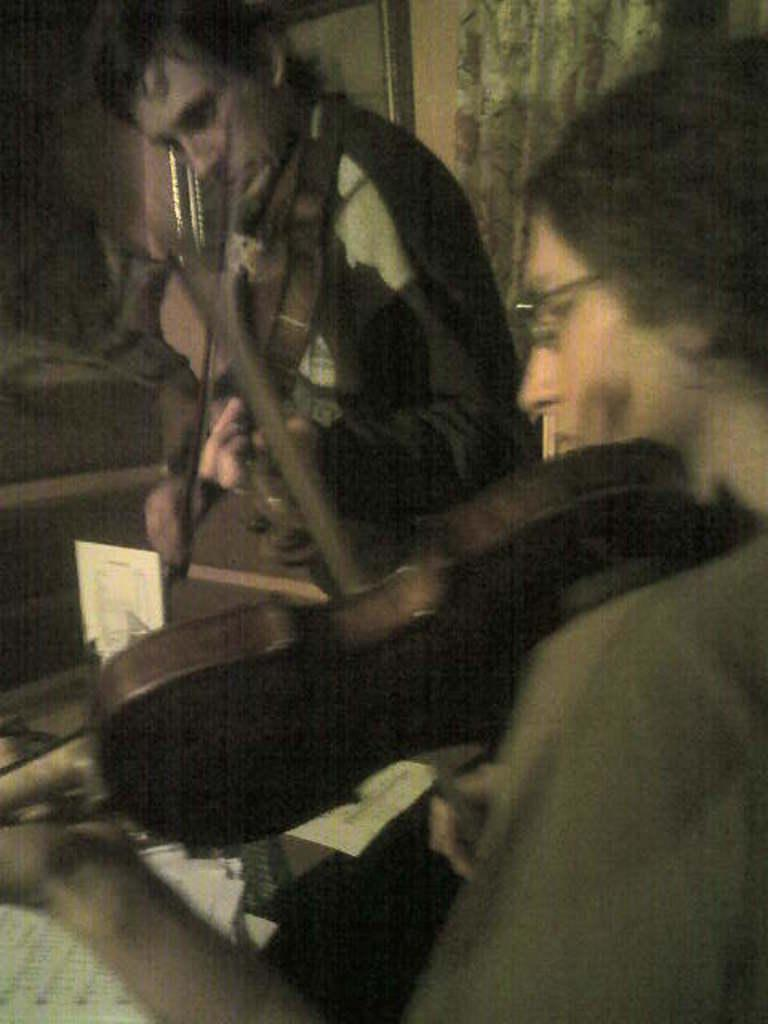How many people are in the image? There are two people in the image. What are the two people doing in the image? The two people are sitting and playing the violin. What might be related to their activity in the image? There are papers in front of them, which could be sheet music. What type of cup can be seen in the hands of the person playing the violin? There is no cup visible in the image; both people are holding violins. What rule is being followed by the person playing the violin? There is no specific rule mentioned or depicted in the image; the focus is on the people playing the violin and the presence of papers. 